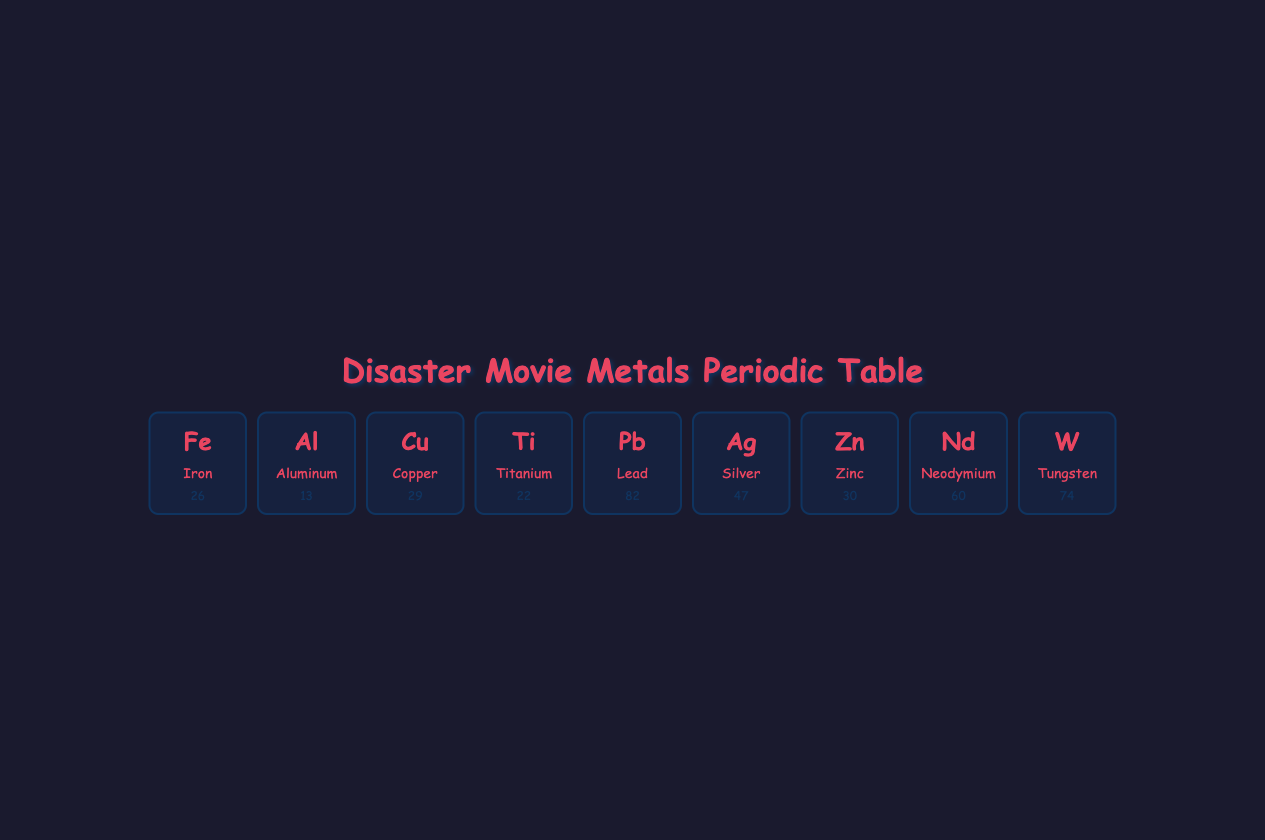What is the atomic number of Aluminum? The atomic number of Aluminum is found in the table, which indicates the specific element. Referring to the row for Aluminum, the atomic number is listed as 13.
Answer: 13 Which element is known for its excellent conductivity and is commonly used in electrical wiring? By examining the common uses listed, Copper is specified for electrical wiring, confirming its role due to its excellent conductivity.
Answer: Copper How many disaster movie examples feature Iron? The disaster movie examples for Iron are listed under the element's description. There are two noted examples: Armageddon and Deep Impact. Consequently, the total is counted as 2.
Answer: 2 Does Titanium have applications in medical implants? The mentioned common uses for Titanium include medical implants. Thus, it is true that it has applications in this area.
Answer: Yes Which element has the highest atomic number in this table? By analyzing the atomic numbers listed for each element, Lead has an atomic number of 82, while Silver has 47 and Tungsten has 74. Therefore, Lead has the highest atomic number in the table.
Answer: Lead What is the combined count of disaster movie examples for Zinc and Silver? The disaster movie examples for Zinc are noted as 2 (Meteor and Volcano), while Silver has 2 (World War Z and The Hunger Games). By adding these two counts together: 2 + 2 equals 4.
Answer: 4 Is Neodymium used for creating strong magnets? Under common uses for Neodymium, it states that it is used for strong magnets. Therefore, the statement is true that Neodymium is used for creating strong magnets.
Answer: Yes What is the impact of Lead on technology regarding radiation protection? Looking at Lead's description, it states that although its use is declining due to toxicity, its density is useful for radiation protection in disaster recovery scenarios, especially in nuclear events.
Answer: Useful for radiation protection How many metals listed are commonly used in aerospace components? Referring to the table, Titanium is specifically mentioned as a common use in aerospace components. Since no other elements have this use noted, the count is 1.
Answer: 1 